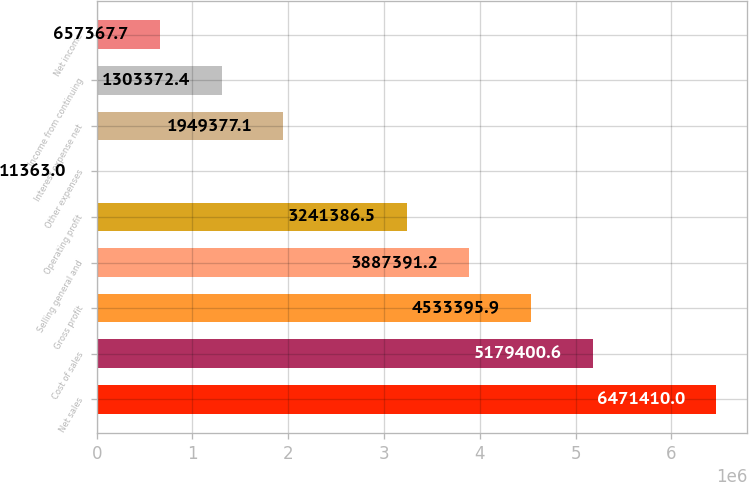Convert chart. <chart><loc_0><loc_0><loc_500><loc_500><bar_chart><fcel>Net sales<fcel>Cost of sales<fcel>Gross profit<fcel>Selling general and<fcel>Operating profit<fcel>Other expenses<fcel>Interest expense net<fcel>Income from continuing<fcel>Net income<nl><fcel>6.47141e+06<fcel>5.1794e+06<fcel>4.5334e+06<fcel>3.88739e+06<fcel>3.24139e+06<fcel>11363<fcel>1.94938e+06<fcel>1.30337e+06<fcel>657368<nl></chart> 